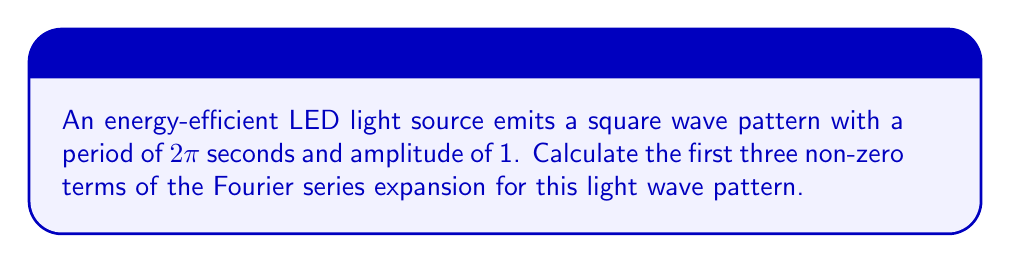Provide a solution to this math problem. Let's approach this step-by-step:

1) The square wave function f(t) can be described as:
   $$f(t) = \begin{cases} 
   1, & 0 \leq t < \pi \\
   -1, & \pi \leq t < 2\pi
   \end{cases}$$

2) The Fourier series for a square wave is given by:
   $$f(t) = \frac{4}{\pi} \sum_{n=1,3,5,...}^{\infty} \frac{1}{n} \sin(n\omega t)$$
   where $\omega = \frac{2\pi}{T} = 1$ (since T = 2π)

3) Expanding this series for the first three non-zero terms:
   $$f(t) \approx \frac{4}{\pi} (\sin(t) + \frac{1}{3}\sin(3t) + \frac{1}{5}\sin(5t))$$

4) Let's calculate each term:
   First term: $\frac{4}{\pi} \sin(t)$
   Second term: $\frac{4}{3\pi} \sin(3t)$
   Third term: $\frac{4}{5\pi} \sin(5t)$

Therefore, the first three non-zero terms of the Fourier series expansion for this square wave light pattern are:

$$\frac{4}{\pi} \sin(t), \frac{4}{3\pi} \sin(3t), \frac{4}{5\pi} \sin(5t)$$
Answer: $\frac{4}{\pi} \sin(t), \frac{4}{3\pi} \sin(3t), \frac{4}{5\pi} \sin(5t)$ 